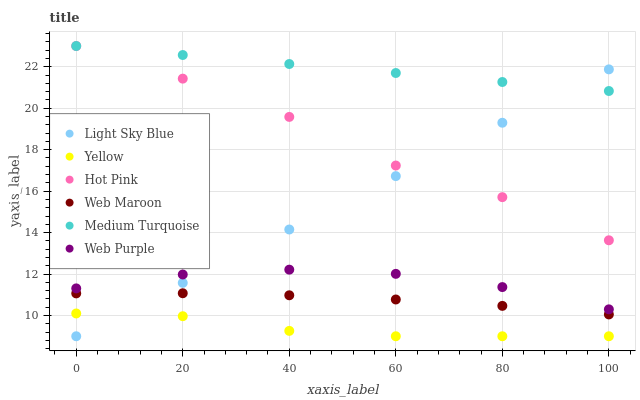Does Yellow have the minimum area under the curve?
Answer yes or no. Yes. Does Medium Turquoise have the maximum area under the curve?
Answer yes or no. Yes. Does Web Maroon have the minimum area under the curve?
Answer yes or no. No. Does Web Maroon have the maximum area under the curve?
Answer yes or no. No. Is Light Sky Blue the smoothest?
Answer yes or no. Yes. Is Hot Pink the roughest?
Answer yes or no. Yes. Is Web Maroon the smoothest?
Answer yes or no. No. Is Web Maroon the roughest?
Answer yes or no. No. Does Yellow have the lowest value?
Answer yes or no. Yes. Does Web Maroon have the lowest value?
Answer yes or no. No. Does Medium Turquoise have the highest value?
Answer yes or no. Yes. Does Web Maroon have the highest value?
Answer yes or no. No. Is Web Purple less than Hot Pink?
Answer yes or no. Yes. Is Medium Turquoise greater than Yellow?
Answer yes or no. Yes. Does Medium Turquoise intersect Light Sky Blue?
Answer yes or no. Yes. Is Medium Turquoise less than Light Sky Blue?
Answer yes or no. No. Is Medium Turquoise greater than Light Sky Blue?
Answer yes or no. No. Does Web Purple intersect Hot Pink?
Answer yes or no. No. 